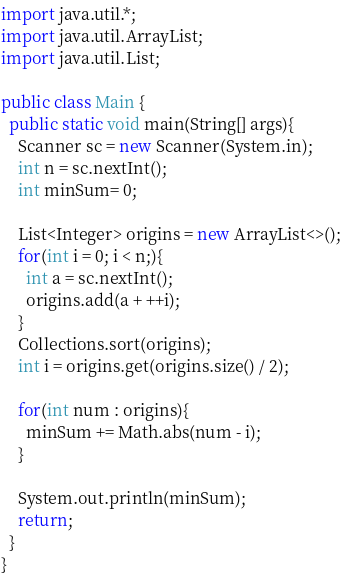Convert code to text. <code><loc_0><loc_0><loc_500><loc_500><_Java_>import java.util.*;
import java.util.ArrayList;
import java.util.List;

public class Main {
  public static void main(String[] args){
    Scanner sc = new Scanner(System.in);
    int n = sc.nextInt();
    int minSum= 0;

    List<Integer> origins = new ArrayList<>();
    for(int i = 0; i < n;){
      int a = sc.nextInt();
      origins.add(a + ++i);
    }
    Collections.sort(origins);
    int i = origins.get(origins.size() / 2);

    for(int num : origins){
      minSum += Math.abs(num - i);
    }

    System.out.println(minSum);
    return;
  }
}</code> 